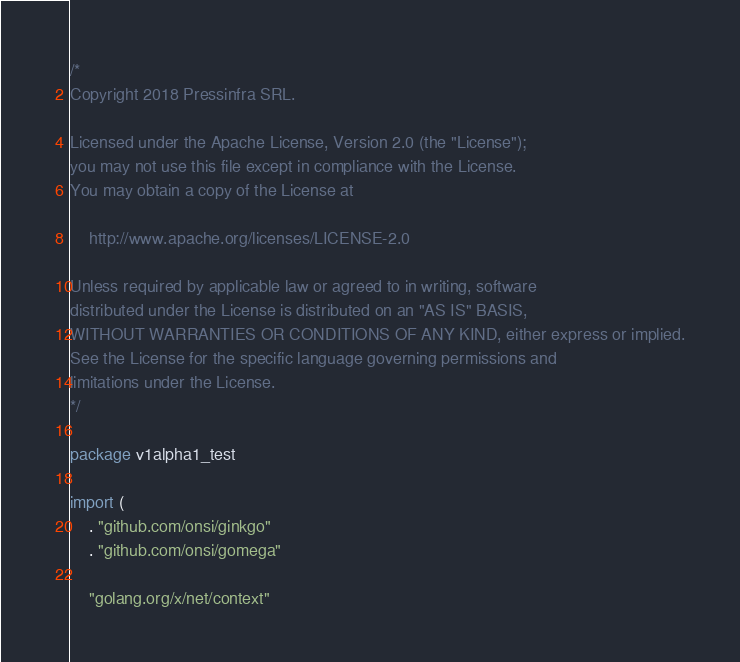Convert code to text. <code><loc_0><loc_0><loc_500><loc_500><_Go_>/*
Copyright 2018 Pressinfra SRL.

Licensed under the Apache License, Version 2.0 (the "License");
you may not use this file except in compliance with the License.
You may obtain a copy of the License at

    http://www.apache.org/licenses/LICENSE-2.0

Unless required by applicable law or agreed to in writing, software
distributed under the License is distributed on an "AS IS" BASIS,
WITHOUT WARRANTIES OR CONDITIONS OF ANY KIND, either express or implied.
See the License for the specific language governing permissions and
limitations under the License.
*/

package v1alpha1_test

import (
	. "github.com/onsi/ginkgo"
	. "github.com/onsi/gomega"

	"golang.org/x/net/context"</code> 